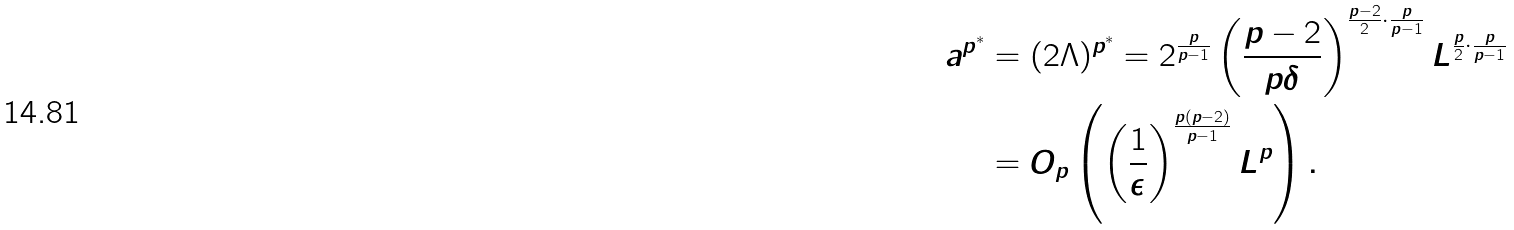<formula> <loc_0><loc_0><loc_500><loc_500>a ^ { p ^ { * } } & = ( 2 \Lambda ) ^ { p ^ { * } } = 2 ^ { \frac { p } { p - 1 } } \left ( \frac { p - 2 } { p \delta } \right ) ^ { \frac { p - 2 } { 2 } \cdot \frac { p } { p - 1 } } L ^ { \frac { p } { 2 } \cdot \frac { p } { p - 1 } } \\ & = O _ { p } \left ( \left ( \frac { 1 } { \epsilon } \right ) ^ { \frac { p ( p - 2 ) } { p - 1 } } L ^ { p } \right ) .</formula> 